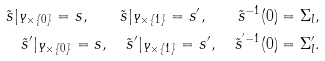<formula> <loc_0><loc_0><loc_500><loc_500>\tilde { s } | _ { Y \times \{ 0 \} } = s , \quad \tilde { s } | _ { Y \times \{ 1 \} } = s ^ { \prime } , \quad \tilde { s } ^ { - 1 } ( 0 ) = \Sigma _ { l } , \\ \tilde { s } ^ { \prime } | _ { Y \times \{ 0 \} } = s , \quad \tilde { s } ^ { \prime } | _ { Y \times \{ 1 \} } = s ^ { \prime } , \quad \tilde { s } ^ { ^ { \prime } - 1 } ( 0 ) = \Sigma _ { l } ^ { \prime } .</formula> 